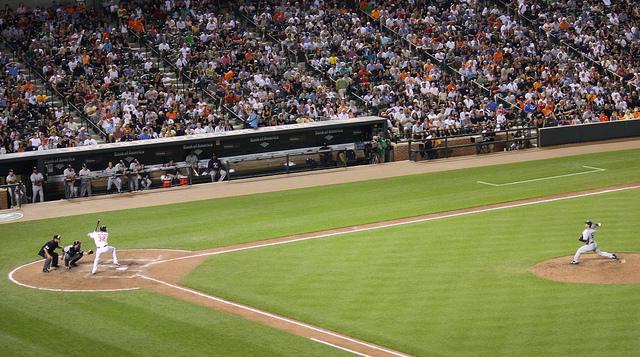Are the stands full?
Concise answer only. Yes. What color is the ground?
Answer briefly. Green. What is the uniform number on the battery?
Concise answer only. 38. 